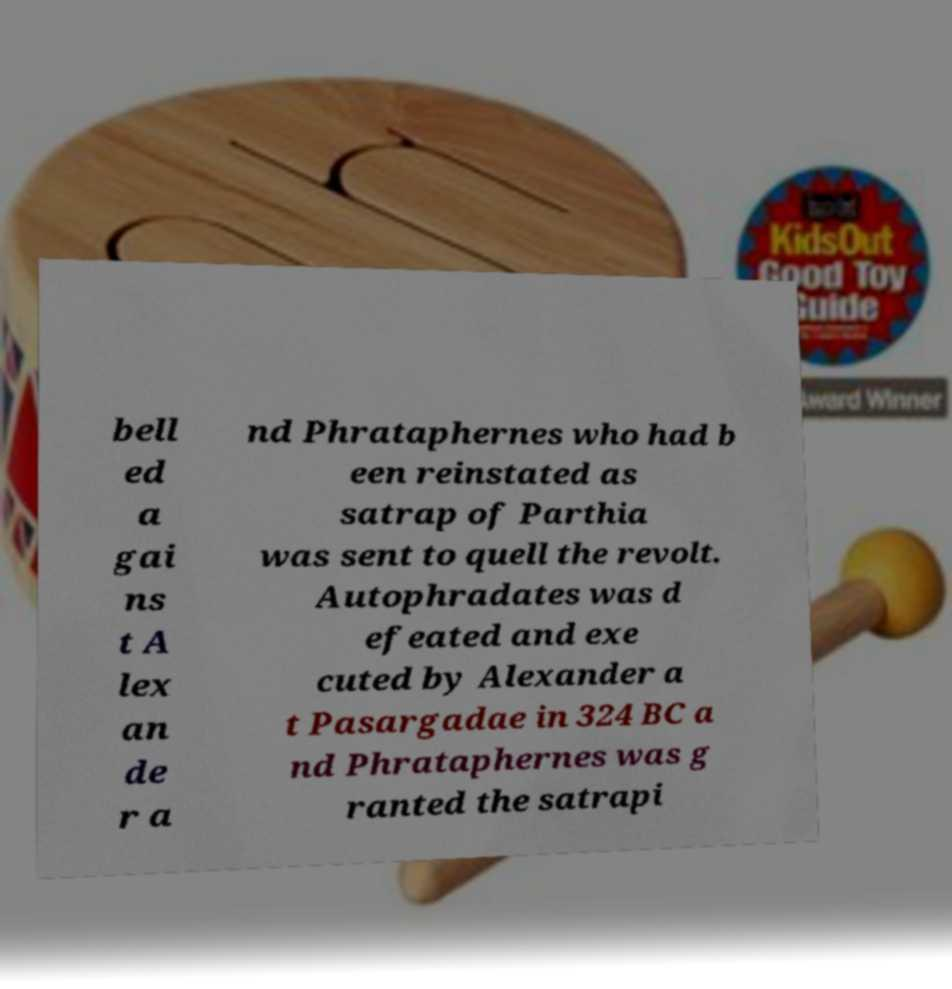What messages or text are displayed in this image? I need them in a readable, typed format. bell ed a gai ns t A lex an de r a nd Phrataphernes who had b een reinstated as satrap of Parthia was sent to quell the revolt. Autophradates was d efeated and exe cuted by Alexander a t Pasargadae in 324 BC a nd Phrataphernes was g ranted the satrapi 